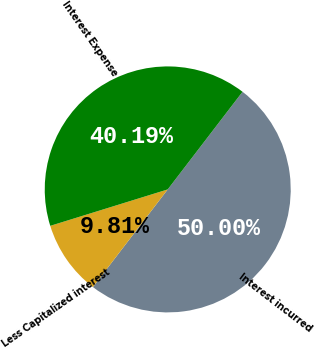Convert chart. <chart><loc_0><loc_0><loc_500><loc_500><pie_chart><fcel>Interest incurred<fcel>Less Capitalized interest<fcel>Interest Expense<nl><fcel>50.0%<fcel>9.81%<fcel>40.19%<nl></chart> 